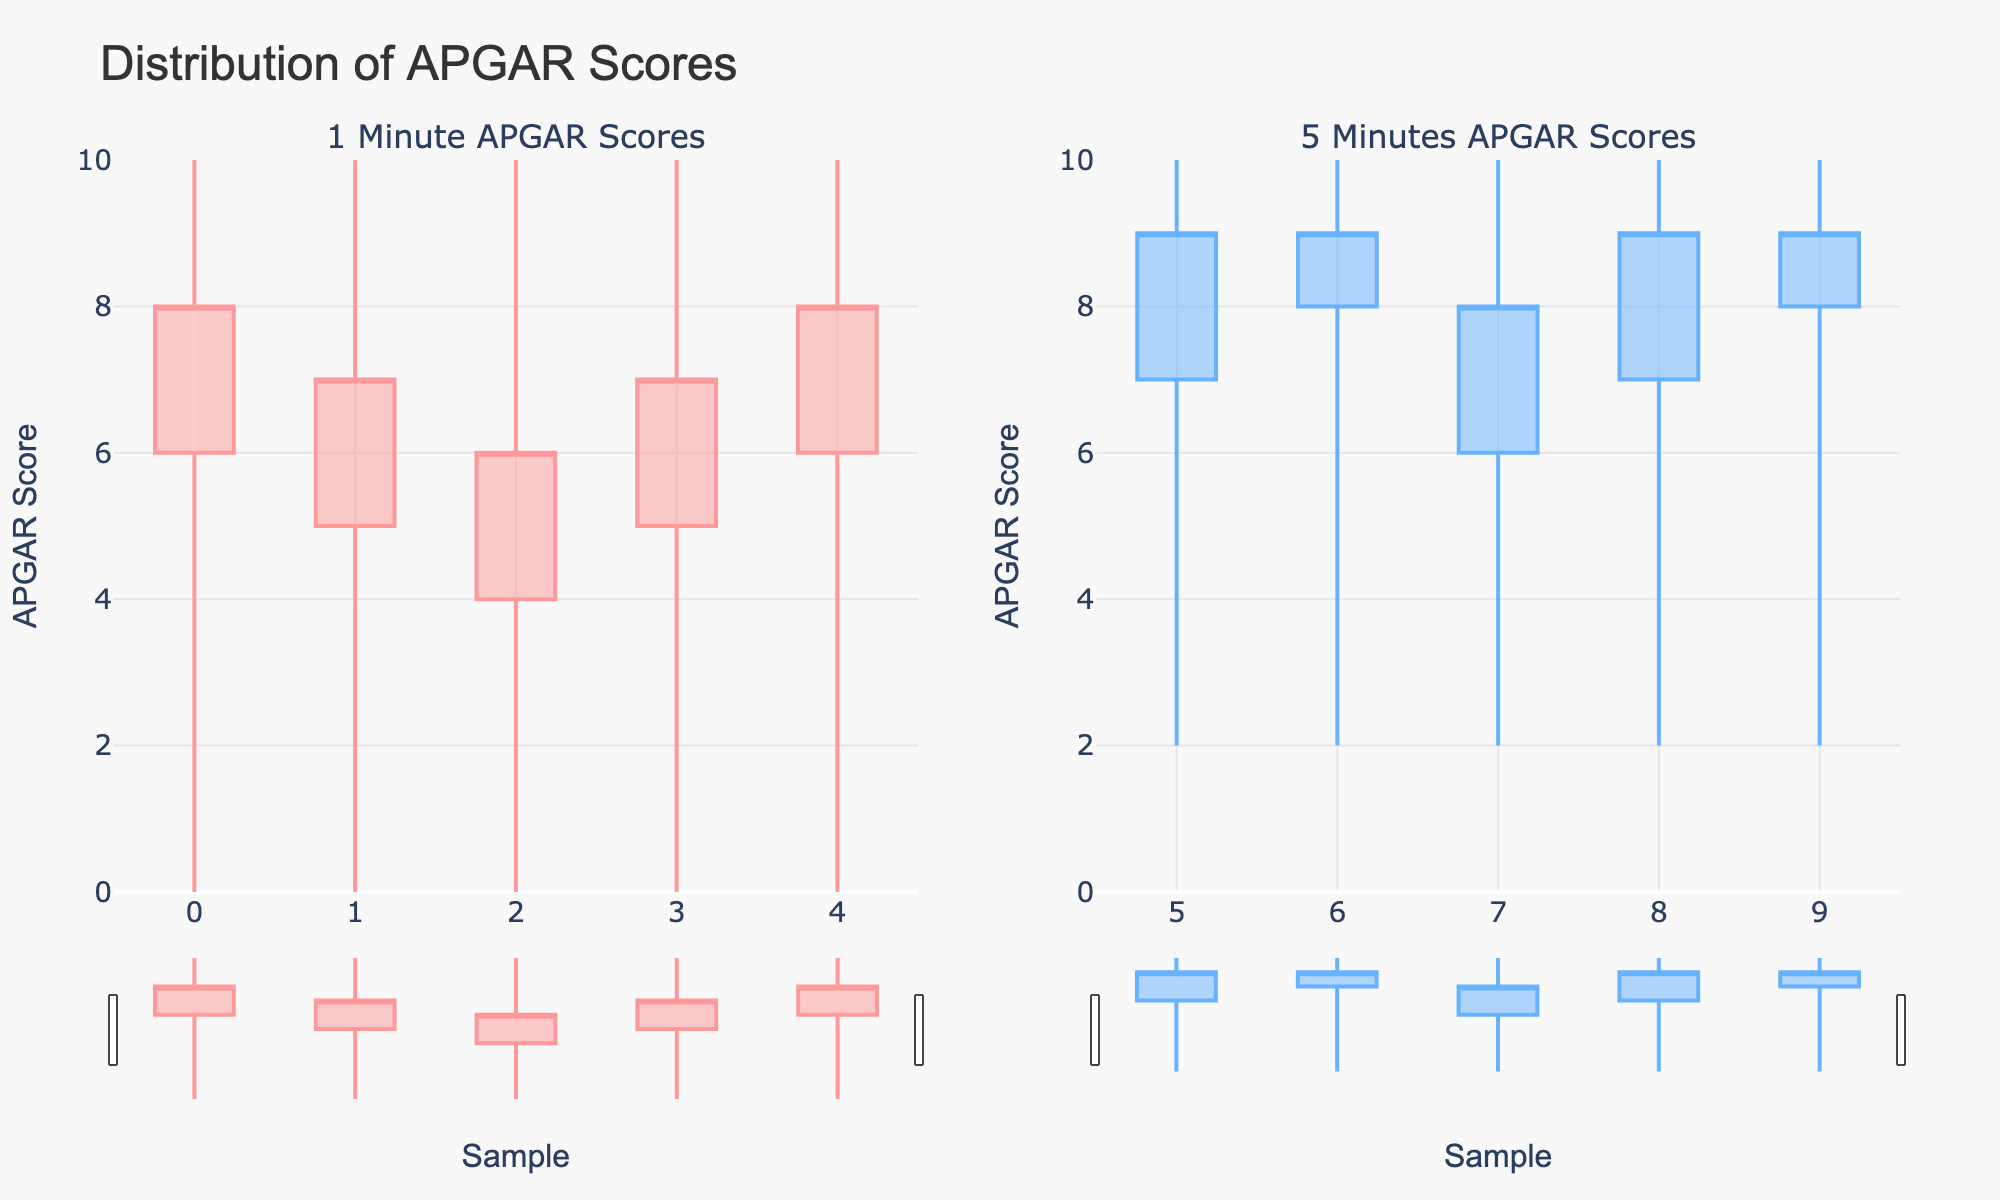what is the title of the plot? The title "Distribution of APGAR Scores" is displayed centrally at the top of the figure. It is intended to provide a summary of what the plot represents. The title is typically the most prominent text on the plot.
Answer: Distribution of APGAR Scores How many subplot panels are present in the figure? The figure has two subplot panels visible, each representing different APGAR scores at specific times. This segmentation helps in comparing the APGAR scores at 1 minute and 5 minutes postpartum.
Answer: 2 What is the range of APGAR scores for the 1 minute time frame? The range for the 1-minute time frame can be determined by looking at the minimum and maximum APGAR scores in that panel. The minimum score is 0, and the maximum score is 10, as depicted by the candlestick extremities.
Answer: 0 to 10 What is the median APGAR score for the 5 minutes time frame? To find the median score for the 5 minutes data, we order the closing values (9, 9, 8, 9, 9) and find the middle value. Since there are five points, the middle value is the 3rd highest score, which is 9.
Answer: 9 Are there any improvements in APGAR scores from 1 minute to 5 minutes? Comparing the panels, we observe that the APGAR scores tend to increase from 1 minute to 5 minutes. This is evidenced by the overall higher closing values and lower minimum scores at the 5-minute mark.
Answer: Yes Which specific APGAR score sample improved the most from 1 minute to 5 minutes? To determine which score had the highest improvement, we compare corresponding samples. Specifically, sample pairs from each timeframe need to be examined to see which one had the largest difference, considering that samples may not perfectly align between time frames.
Answer: Sample with starting Open of 6 and closing of 8 at 1 minute to 8 and 9 at 5 minutes With respect to the opening APGAR scores, what is the average change from 1 minute to 5 minutes? Calculate the average change by subtracting each 1-minute Open value from the 5-minute Open value and then averaging these differences. The calculation steps involve 7-6, 8-5, 6-4, 7-5, and 8-6 which sums up to 11 divided by 5 resulting in an average change of 2.2.
Answer: 2.2 Which time period has more variability in APGAR scores? Variability is typically assessed by comparing the range and spread of values. From the figure, the 1-minute period displays a higher range (0 to 10) compared to the 5-minute period which shows a narrower range (2 to 10), indicating more variability at 1 minute.
Answer: 1 minute What color represents the increasing trend in 5 minutes APGAR scores? The color representing an increasing trend in the 5 minutes APGAR scores is observed from the color of the candlestick plots in that panel. The specific color used for rising trends in the 5-minute subplot is a shade of blue.
Answer: Blue 